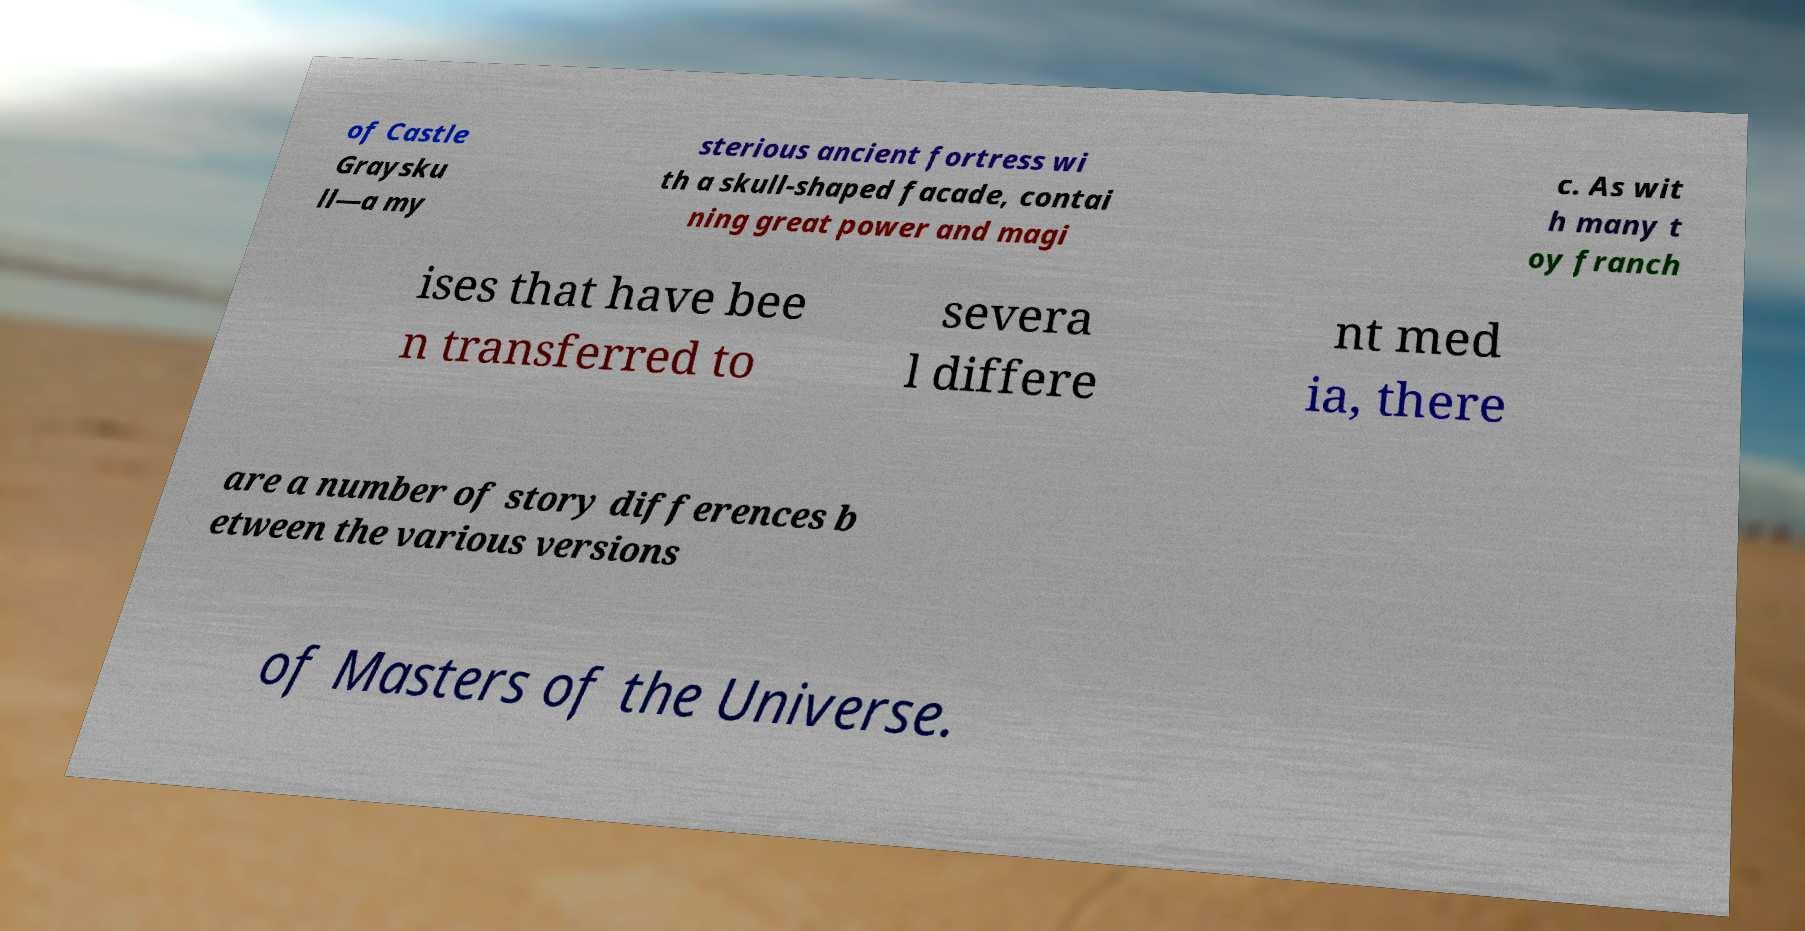Can you read and provide the text displayed in the image?This photo seems to have some interesting text. Can you extract and type it out for me? of Castle Graysku ll—a my sterious ancient fortress wi th a skull-shaped facade, contai ning great power and magi c. As wit h many t oy franch ises that have bee n transferred to severa l differe nt med ia, there are a number of story differences b etween the various versions of Masters of the Universe. 